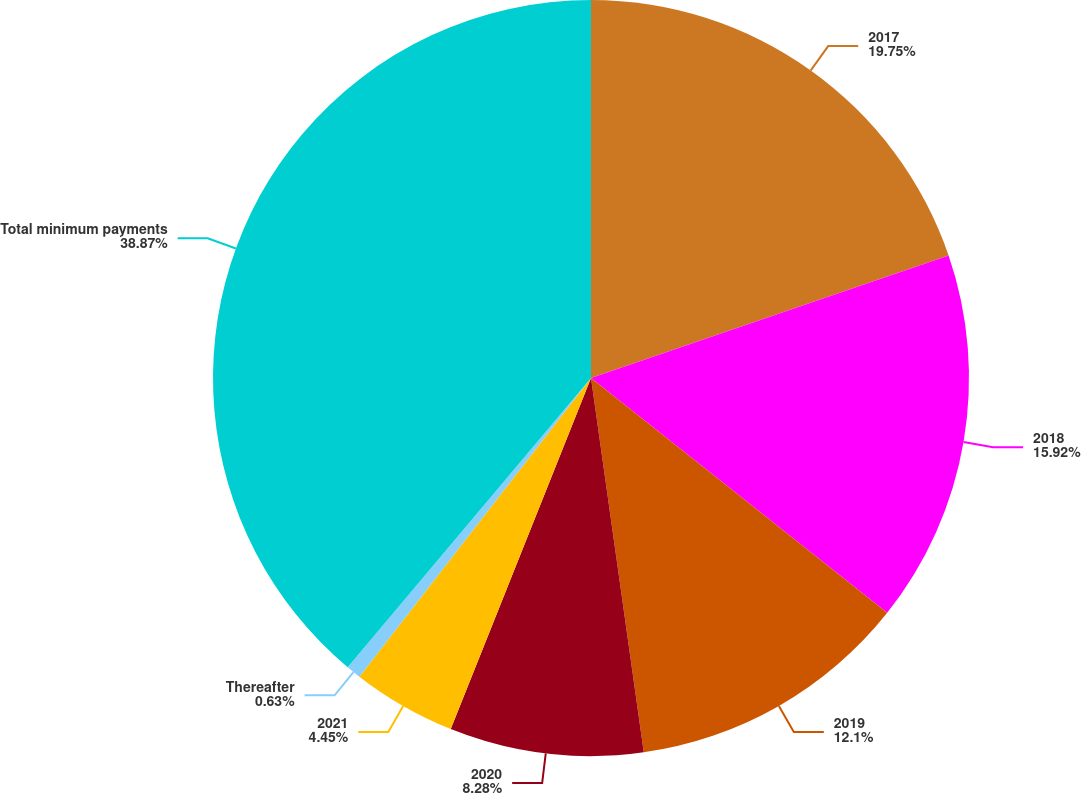Convert chart. <chart><loc_0><loc_0><loc_500><loc_500><pie_chart><fcel>2017<fcel>2018<fcel>2019<fcel>2020<fcel>2021<fcel>Thereafter<fcel>Total minimum payments<nl><fcel>19.75%<fcel>15.92%<fcel>12.1%<fcel>8.28%<fcel>4.45%<fcel>0.63%<fcel>38.87%<nl></chart> 